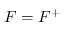<formula> <loc_0><loc_0><loc_500><loc_500>F = F ^ { + }</formula> 